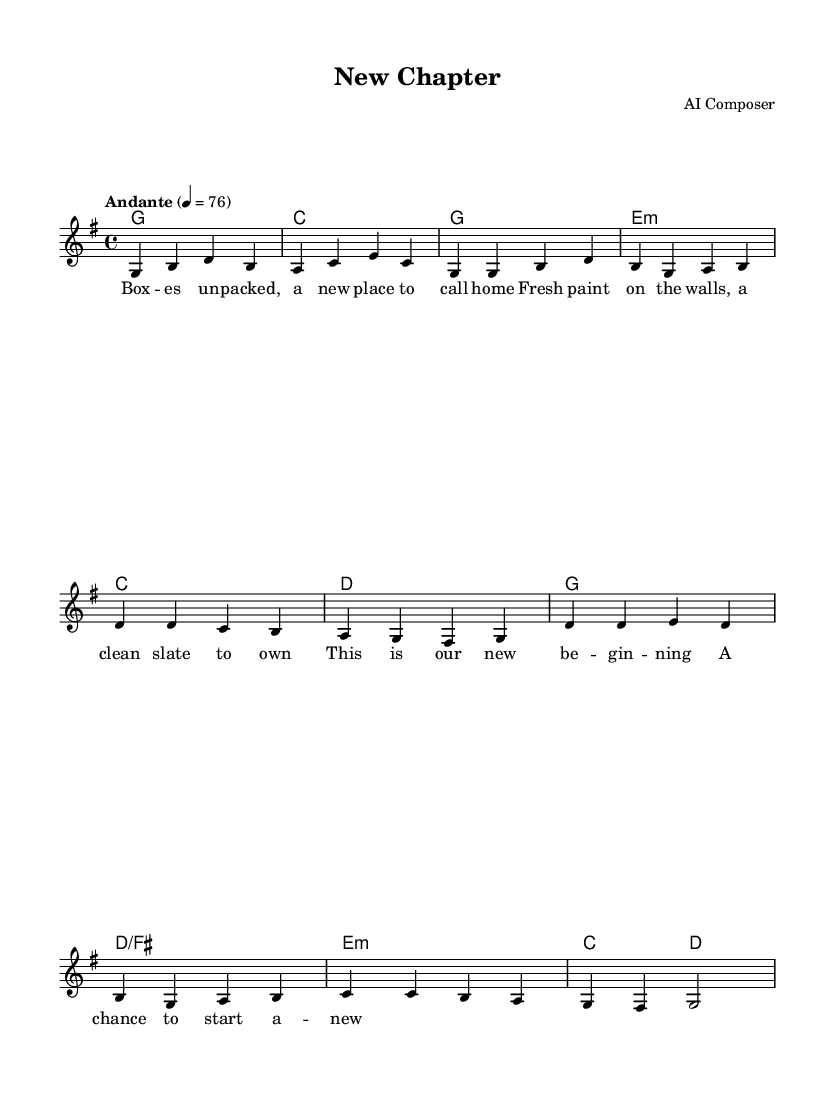What is the key signature of this music? The key signature is G major, which has one sharp (F#). This can be identified by looking at the initial part of the sheet music where the clef and a key signature with one sharp is indicated.
Answer: G major What is the time signature of this music? The time signature is 4/4, which indicates there are four beats in each measure and a quarter note receives one beat. This can be seen at the beginning of the sheet music right after the clef and key signature.
Answer: 4/4 What is the tempo marking of this piece? The tempo marking indicates "Andante" at a speed of 76 beats per minute. This is indicated in the text right above the staff at the beginning of the music.
Answer: Andante, 76 How many measures are there in the melody section? The melody section consists of 8 measures, as counted from the first note to the last note of the melody shown in the score.
Answer: 8 What is the first lyric of the song? The first lyric of the song is "Boxes." This is shown at the start of the lyric mode section in the score.
Answer: Boxes How many chords are used in the chorus? The chorus utilizes 4 chords, identified in the chord mode section. Each chord corresponds to specific measures in the music.
Answer: 4 What theme do the lyrics convey? The lyrics convey a theme of new beginnings and fresh starts, as highlighted in phrases like "a new place to call home" and "a clean slate." This overall context of the lyrics encapsulates the essence of romance and starting anew.
Answer: New beginnings 